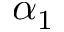<formula> <loc_0><loc_0><loc_500><loc_500>\alpha _ { 1 }</formula> 